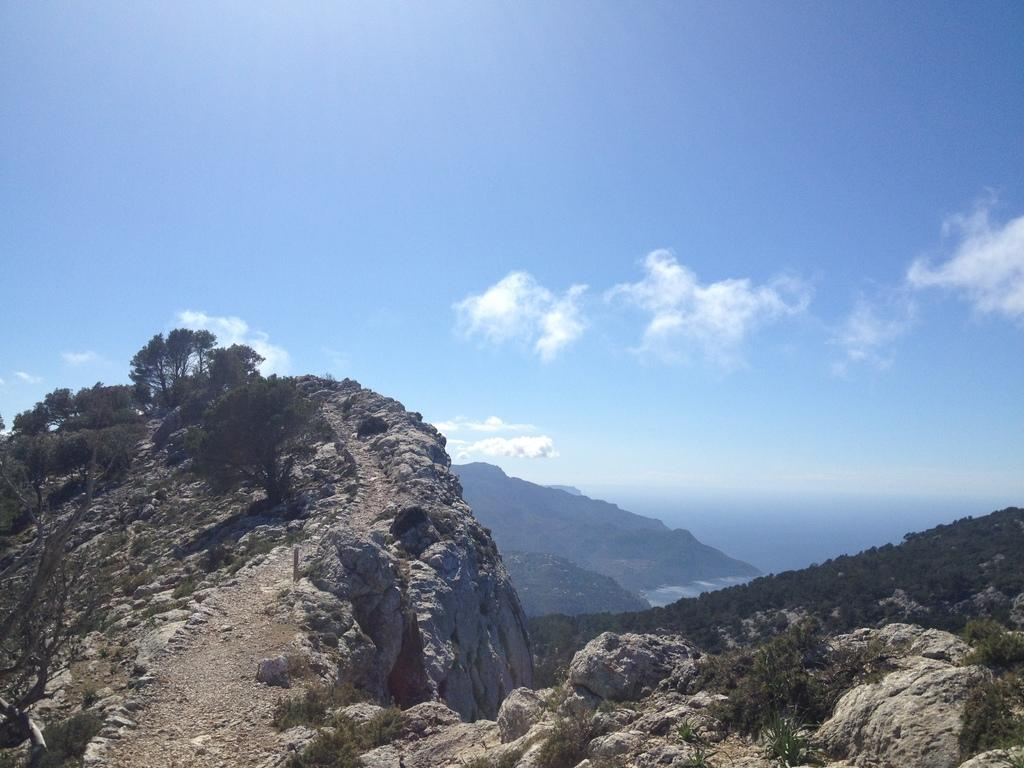Where was the image taken? The image was clicked outside. What geographical features can be seen in the image? There are mountains and trees in the image. What is visible in the sky at the top of the image? There are clouds in the sky at the top of the image. What type of oatmeal is being served in the image? There is no oatmeal present in the image. What agreement was reached between the mountains and the trees in the image? There is no agreement between the mountains and the trees in the image, as they are inanimate objects. 